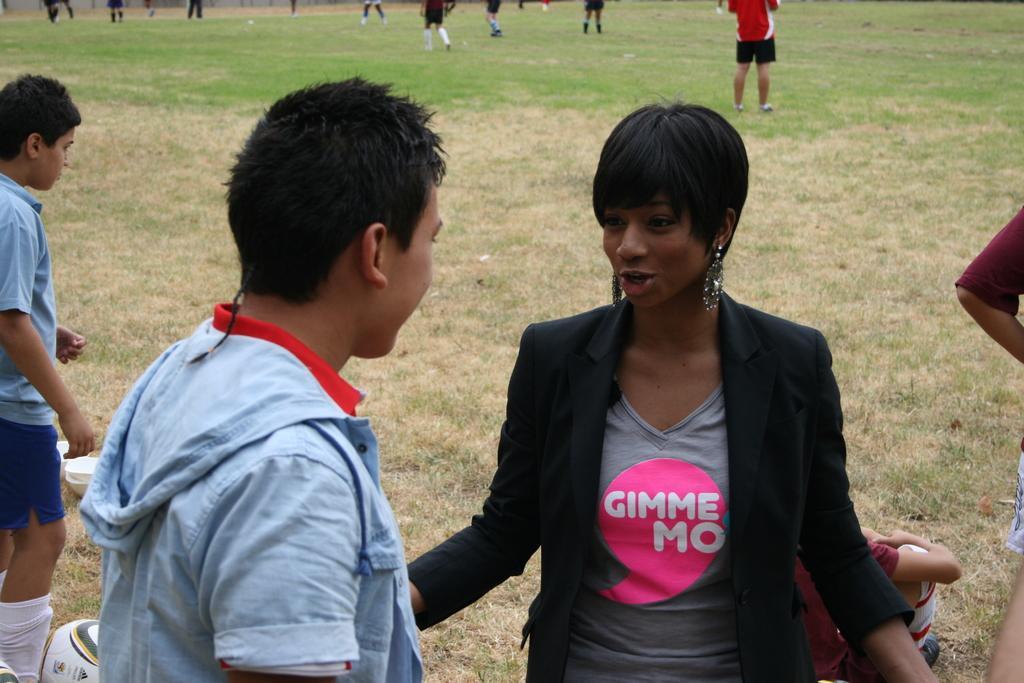Could you give a brief overview of what you see in this image? In this image we can see some group of persons standing and some are playing game and in the foreground of the image we can see a woman wearing black color dress talking to the man who is wearing blue color dress and there is a ball. 